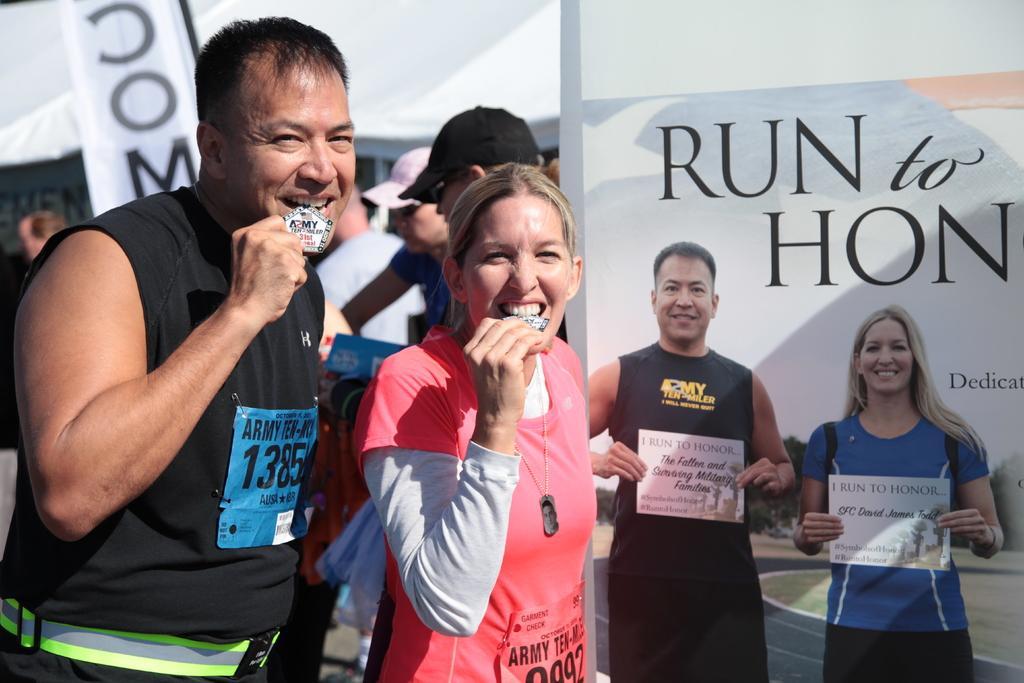Could you give a brief overview of what you see in this image? In this image there is a man and woman are standing holding a medal in their hands and keeping in the mouth, in the background there are people standing and there are posters, on that posters there is some text and there are pictures of man and woman. 